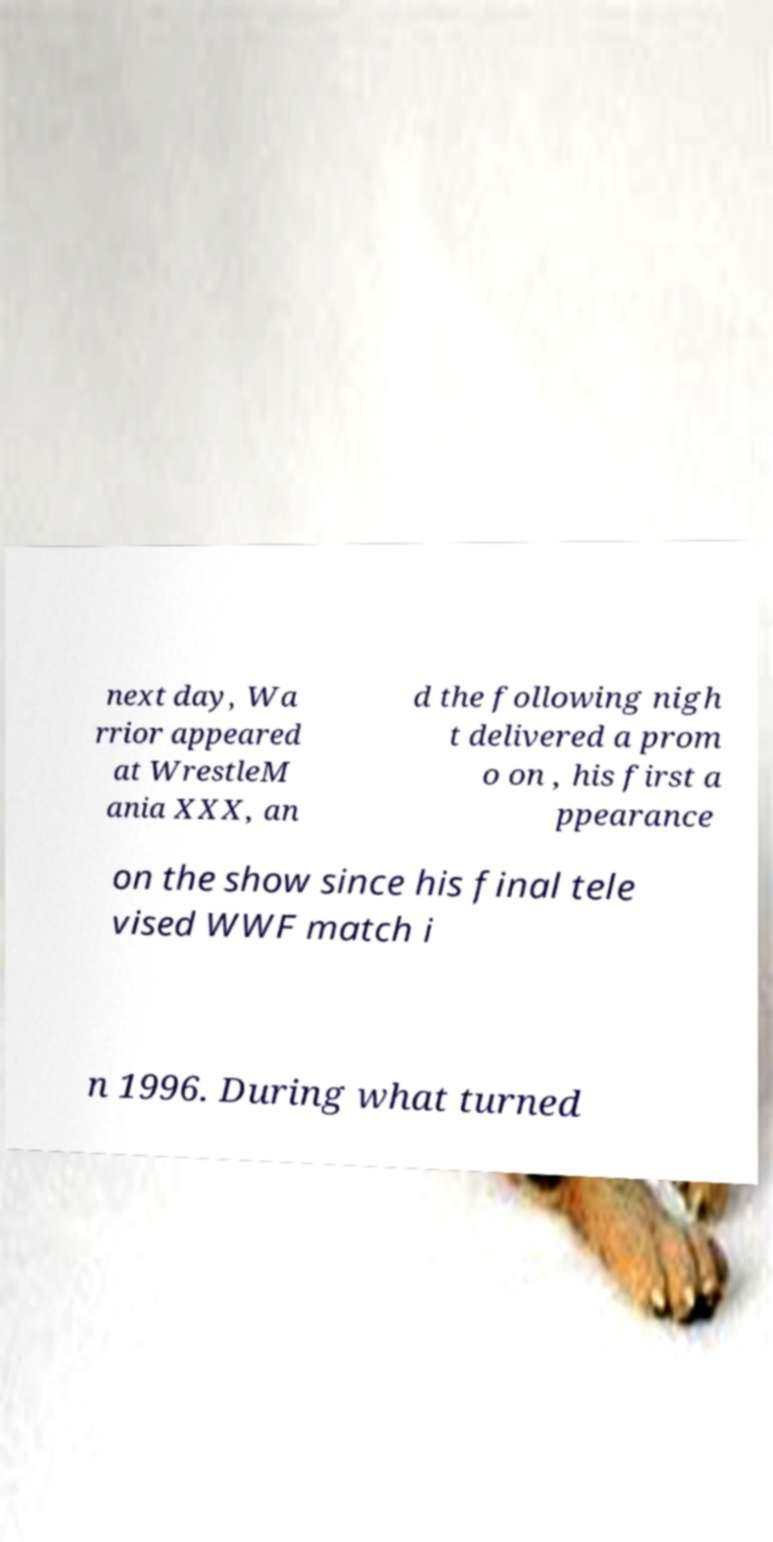Please identify and transcribe the text found in this image. next day, Wa rrior appeared at WrestleM ania XXX, an d the following nigh t delivered a prom o on , his first a ppearance on the show since his final tele vised WWF match i n 1996. During what turned 